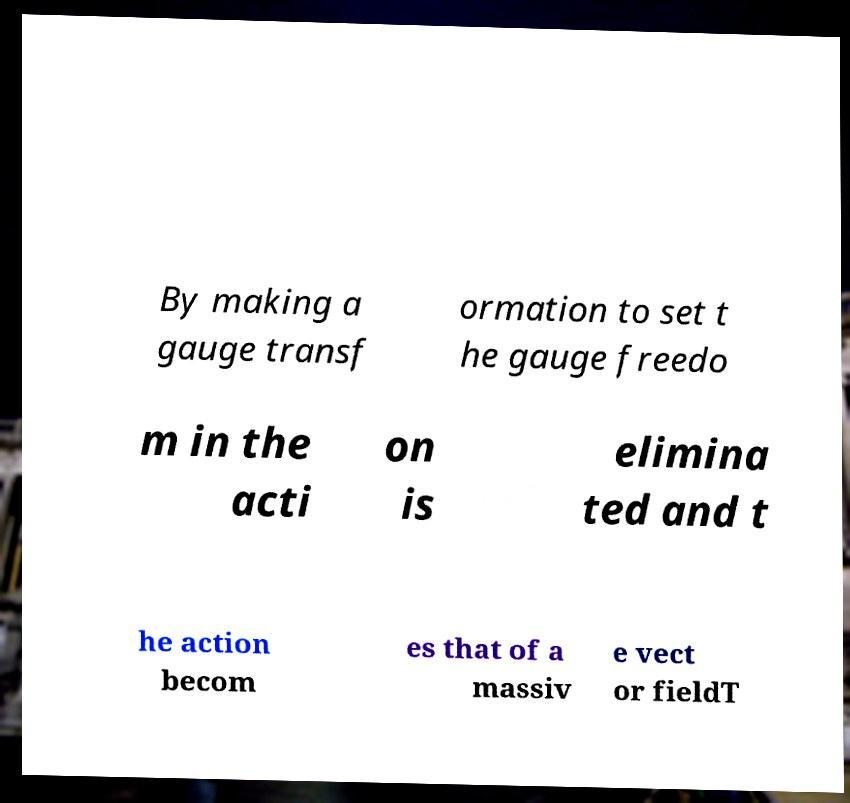I need the written content from this picture converted into text. Can you do that? By making a gauge transf ormation to set t he gauge freedo m in the acti on is elimina ted and t he action becom es that of a massiv e vect or fieldT 